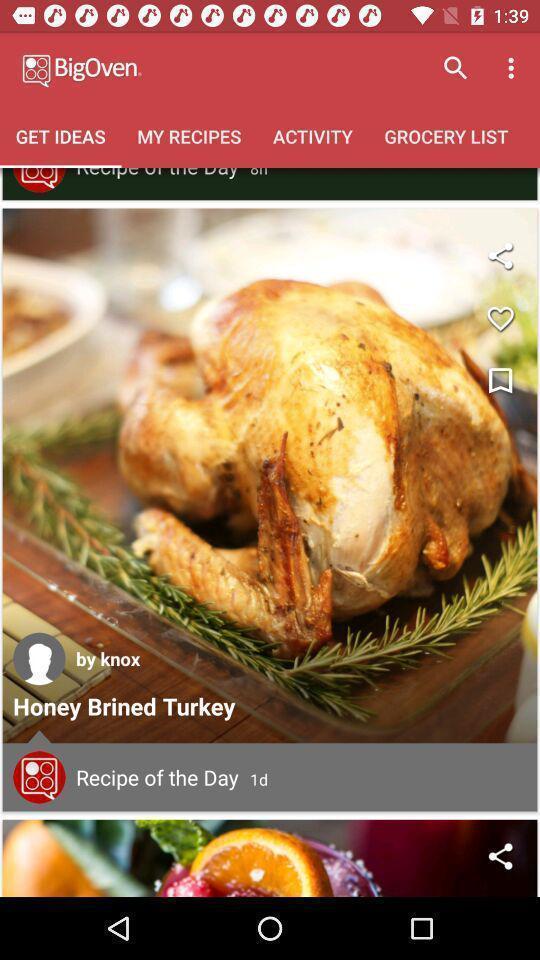Give me a summary of this screen capture. Screen displaying multiple features of a cooking application. 